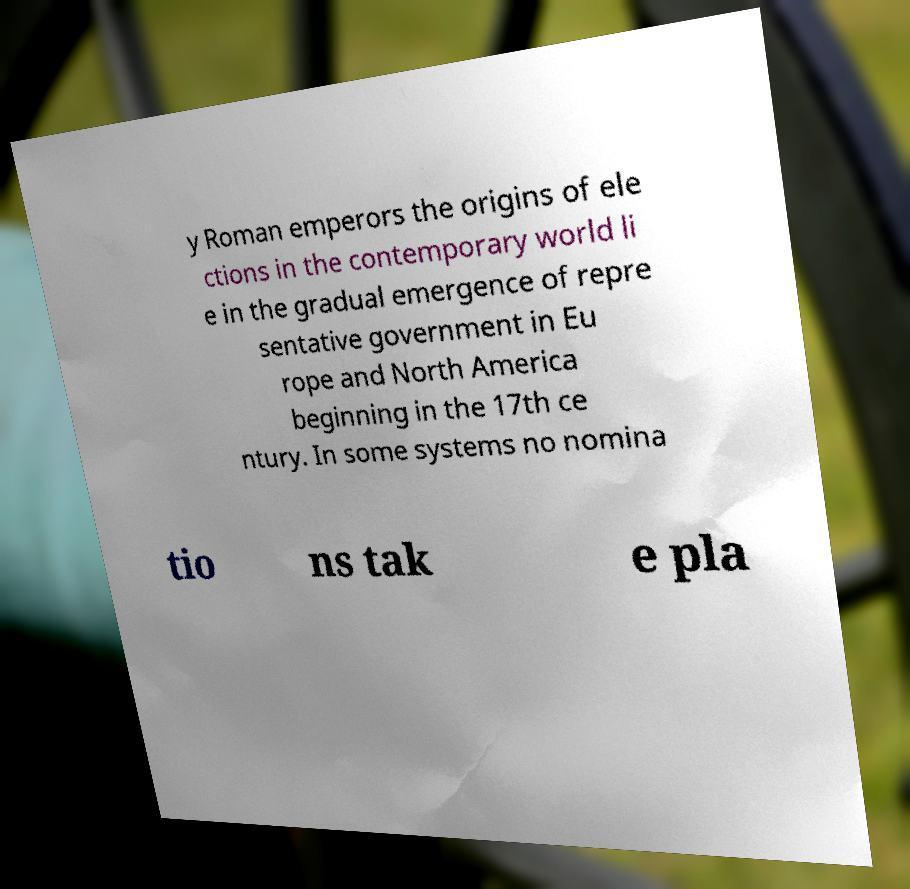Can you accurately transcribe the text from the provided image for me? y Roman emperors the origins of ele ctions in the contemporary world li e in the gradual emergence of repre sentative government in Eu rope and North America beginning in the 17th ce ntury. In some systems no nomina tio ns tak e pla 